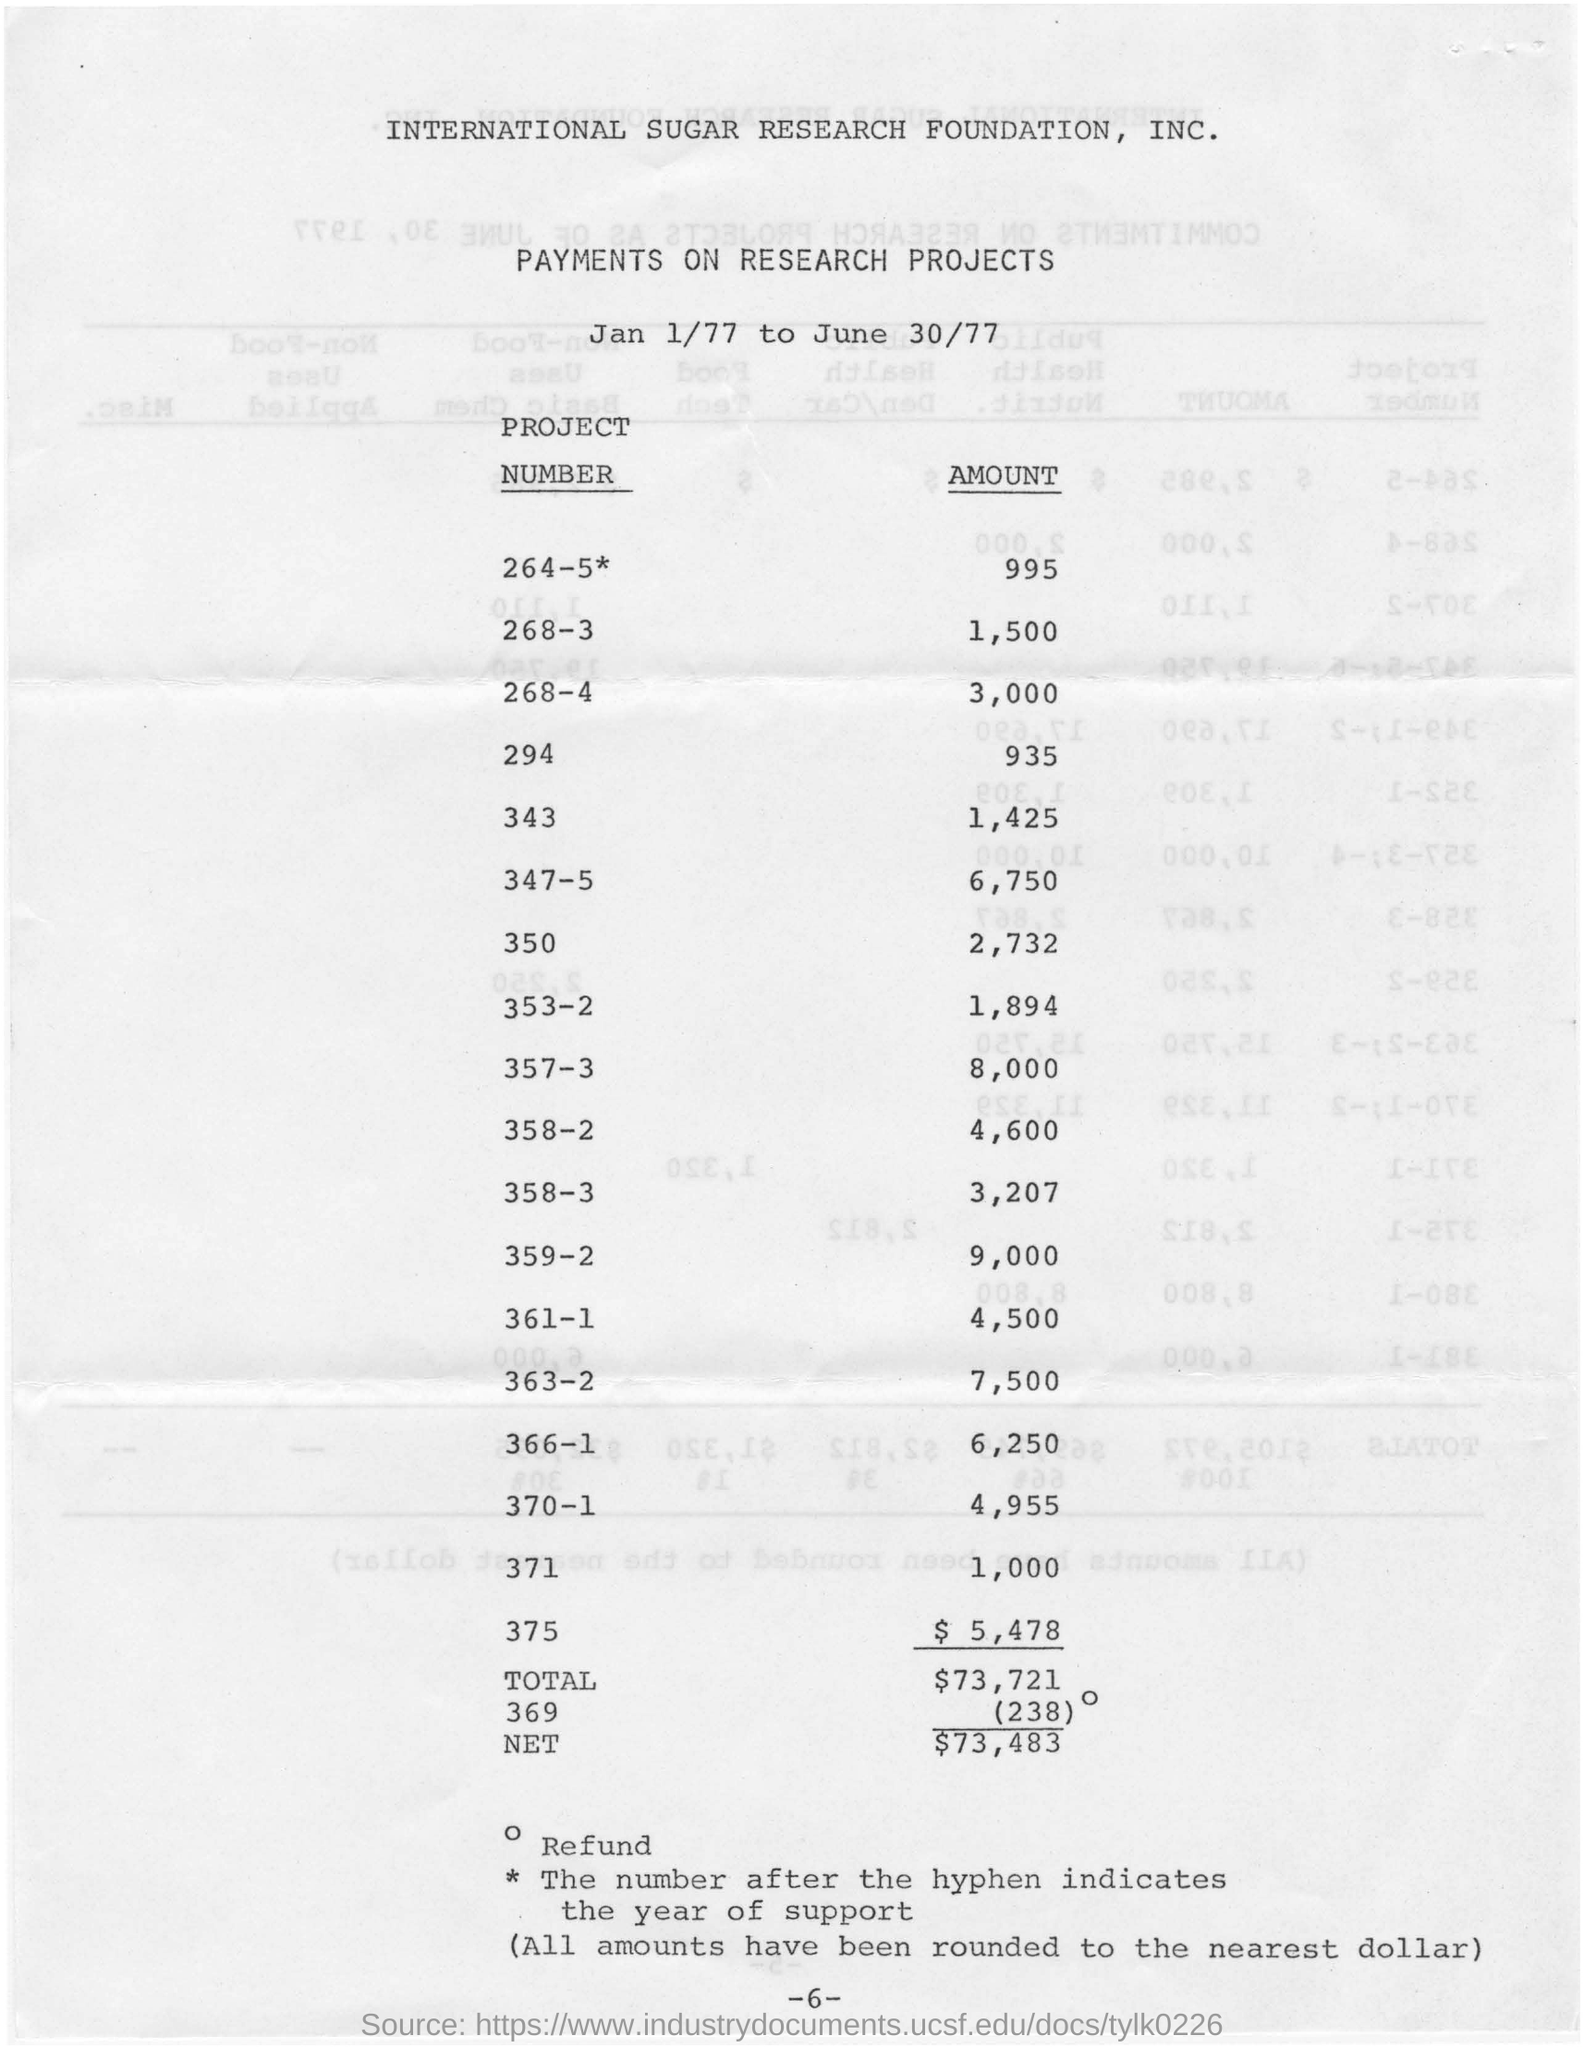Identify some key points in this picture. The amount for project number 350 is 2,732. The amount for project number 370-1 is $4,955. The amount for project number 294 is 935. 